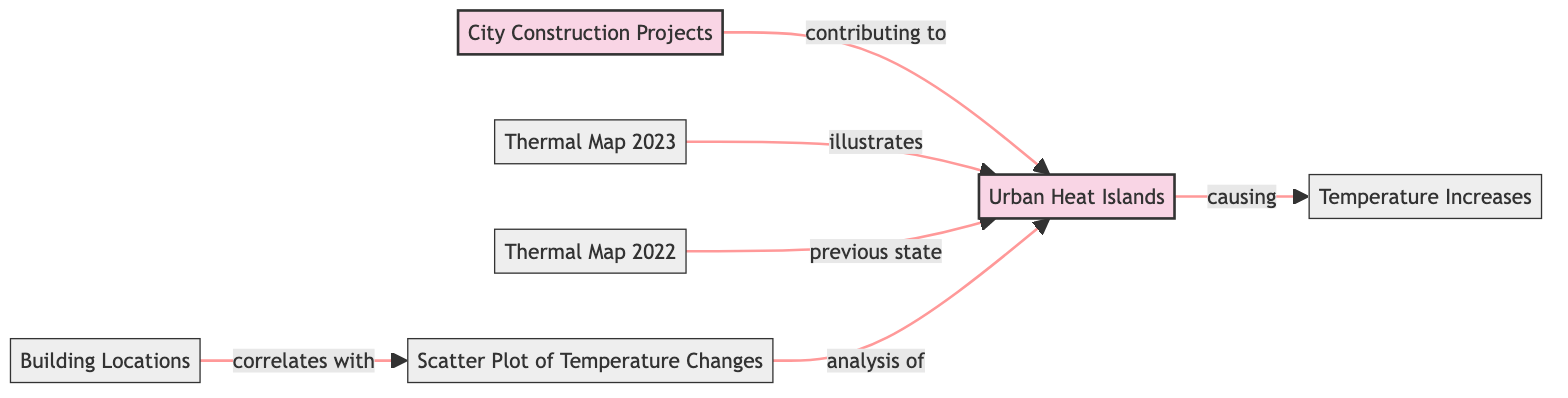What are the main concepts represented in the diagram? The diagram features three main concepts: Urban Heat Islands, City Construction Projects, and Temperature Increases. These concepts are highlighted as distinct nodes that are linked in the flowchart.
Answer: Urban Heat Islands, City Construction Projects, Temperature Increases How many thermal maps are included in the diagram? There are two thermal maps in the diagram indicated by nodes labeled Thermal Map 2023 and Thermal Map 2022. This can be counted by visually identifying the distinct thermal map nodes.
Answer: 2 What does the arrow from City Construction Projects to Urban Heat Islands imply? The arrow signifies that City Construction Projects are contributing to the growth of Urban Heat Islands. This relationship is explicitly stated in the diagram.
Answer: Contributing to What type of data is shown in the scatter plot within the diagram? The scatter plot demonstrates the analysis of temperature changes related to Urban Heat Islands. This is evident in the label associated with the scatter plot node.
Answer: Temperature changes Which thermal map reflects the previous state of Urban Heat Islands? The label on the node indicates that Thermal Map 2022 represents the previous state of Urban Heat Islands, as contrasted with Thermal Map 2023.
Answer: Thermal Map 2022 What do Building Locations correlate with in the diagram? The Building Locations correlate with the scatter plot of temperature changes, as indicated by the arrow linking these two nodes.
Answer: Scatter Plot of Temperature Changes How do Urban Heat Islands relate to Temperature Increases? Urban Heat Islands are shown to cause Temperature Increases, which is demonstrated by the direct connection with an arrow pointing from Urban Heat Islands to Temperature Increases.
Answer: Causing Explain the significance of the link from thermal maps to Urban Heat Islands. The thermal maps illustrate the current and previous states of Urban Heat Islands, providing a visual representation of their development over time. This relationship connects these two concepts directly in understanding urban heat dynamics.
Answer: Illustrates What is the role of temperature changes in the context of this diagram? Temperature changes serve as a mechanism to analyze the impact of Urban Heat Islands, indicated by the link from the scatter plot to Urban Heat Islands. It emphasizes temperature change as a measurable effect in this context.
Answer: Analysis of 